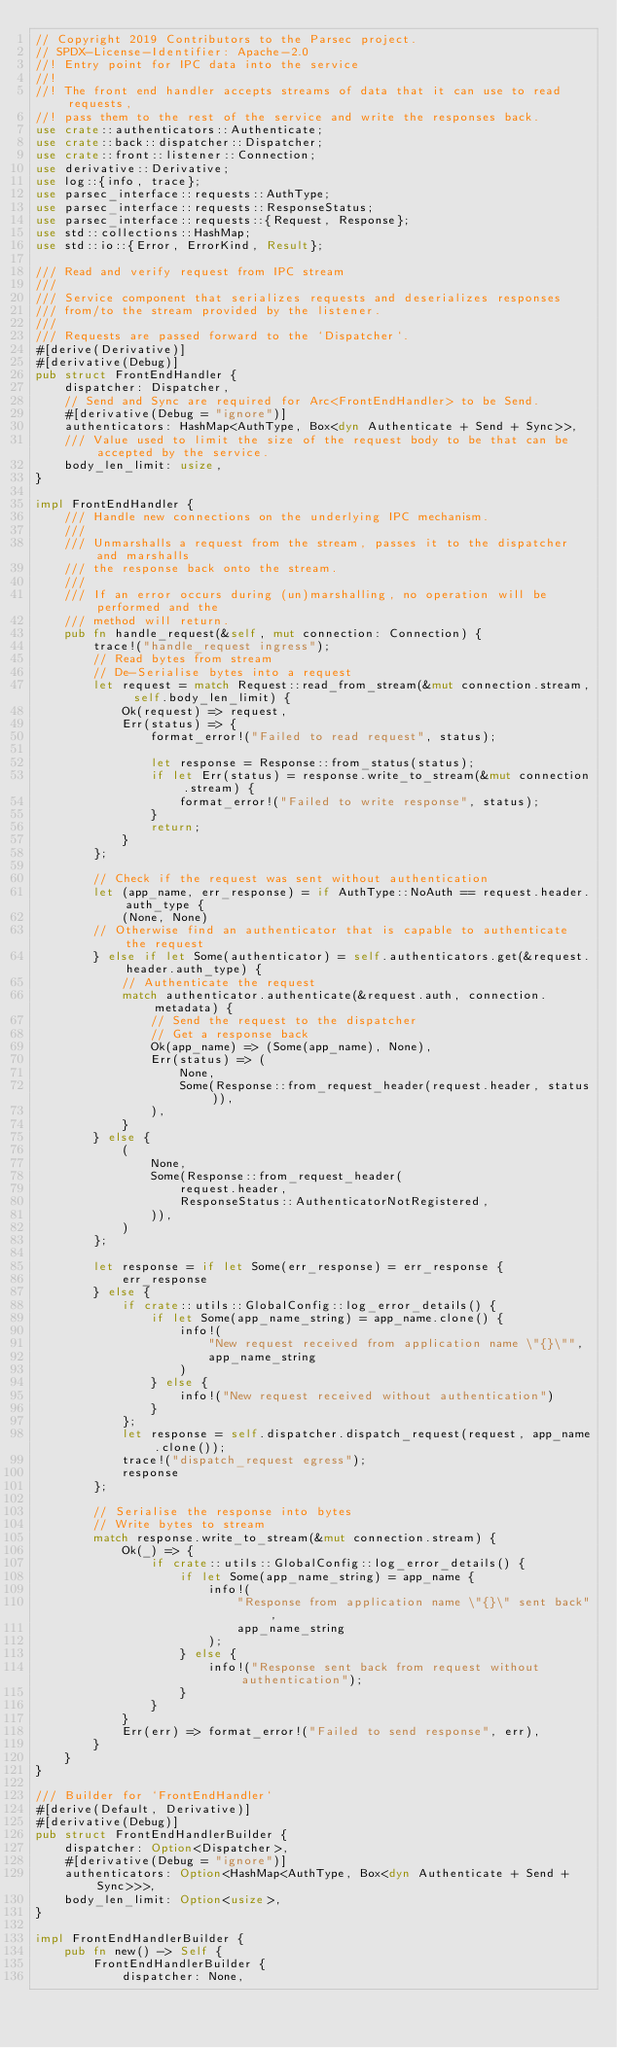<code> <loc_0><loc_0><loc_500><loc_500><_Rust_>// Copyright 2019 Contributors to the Parsec project.
// SPDX-License-Identifier: Apache-2.0
//! Entry point for IPC data into the service
//!
//! The front end handler accepts streams of data that it can use to read requests,
//! pass them to the rest of the service and write the responses back.
use crate::authenticators::Authenticate;
use crate::back::dispatcher::Dispatcher;
use crate::front::listener::Connection;
use derivative::Derivative;
use log::{info, trace};
use parsec_interface::requests::AuthType;
use parsec_interface::requests::ResponseStatus;
use parsec_interface::requests::{Request, Response};
use std::collections::HashMap;
use std::io::{Error, ErrorKind, Result};

/// Read and verify request from IPC stream
///
/// Service component that serializes requests and deserializes responses
/// from/to the stream provided by the listener.
///
/// Requests are passed forward to the `Dispatcher`.
#[derive(Derivative)]
#[derivative(Debug)]
pub struct FrontEndHandler {
    dispatcher: Dispatcher,
    // Send and Sync are required for Arc<FrontEndHandler> to be Send.
    #[derivative(Debug = "ignore")]
    authenticators: HashMap<AuthType, Box<dyn Authenticate + Send + Sync>>,
    /// Value used to limit the size of the request body to be that can be accepted by the service.
    body_len_limit: usize,
}

impl FrontEndHandler {
    /// Handle new connections on the underlying IPC mechanism.
    ///
    /// Unmarshalls a request from the stream, passes it to the dispatcher and marshalls
    /// the response back onto the stream.
    ///
    /// If an error occurs during (un)marshalling, no operation will be performed and the
    /// method will return.
    pub fn handle_request(&self, mut connection: Connection) {
        trace!("handle_request ingress");
        // Read bytes from stream
        // De-Serialise bytes into a request
        let request = match Request::read_from_stream(&mut connection.stream, self.body_len_limit) {
            Ok(request) => request,
            Err(status) => {
                format_error!("Failed to read request", status);

                let response = Response::from_status(status);
                if let Err(status) = response.write_to_stream(&mut connection.stream) {
                    format_error!("Failed to write response", status);
                }
                return;
            }
        };

        // Check if the request was sent without authentication
        let (app_name, err_response) = if AuthType::NoAuth == request.header.auth_type {
            (None, None)
        // Otherwise find an authenticator that is capable to authenticate the request
        } else if let Some(authenticator) = self.authenticators.get(&request.header.auth_type) {
            // Authenticate the request
            match authenticator.authenticate(&request.auth, connection.metadata) {
                // Send the request to the dispatcher
                // Get a response back
                Ok(app_name) => (Some(app_name), None),
                Err(status) => (
                    None,
                    Some(Response::from_request_header(request.header, status)),
                ),
            }
        } else {
            (
                None,
                Some(Response::from_request_header(
                    request.header,
                    ResponseStatus::AuthenticatorNotRegistered,
                )),
            )
        };

        let response = if let Some(err_response) = err_response {
            err_response
        } else {
            if crate::utils::GlobalConfig::log_error_details() {
                if let Some(app_name_string) = app_name.clone() {
                    info!(
                        "New request received from application name \"{}\"",
                        app_name_string
                    )
                } else {
                    info!("New request received without authentication")
                }
            };
            let response = self.dispatcher.dispatch_request(request, app_name.clone());
            trace!("dispatch_request egress");
            response
        };

        // Serialise the response into bytes
        // Write bytes to stream
        match response.write_to_stream(&mut connection.stream) {
            Ok(_) => {
                if crate::utils::GlobalConfig::log_error_details() {
                    if let Some(app_name_string) = app_name {
                        info!(
                            "Response from application name \"{}\" sent back",
                            app_name_string
                        );
                    } else {
                        info!("Response sent back from request without authentication");
                    }
                }
            }
            Err(err) => format_error!("Failed to send response", err),
        }
    }
}

/// Builder for `FrontEndHandler`
#[derive(Default, Derivative)]
#[derivative(Debug)]
pub struct FrontEndHandlerBuilder {
    dispatcher: Option<Dispatcher>,
    #[derivative(Debug = "ignore")]
    authenticators: Option<HashMap<AuthType, Box<dyn Authenticate + Send + Sync>>>,
    body_len_limit: Option<usize>,
}

impl FrontEndHandlerBuilder {
    pub fn new() -> Self {
        FrontEndHandlerBuilder {
            dispatcher: None,</code> 